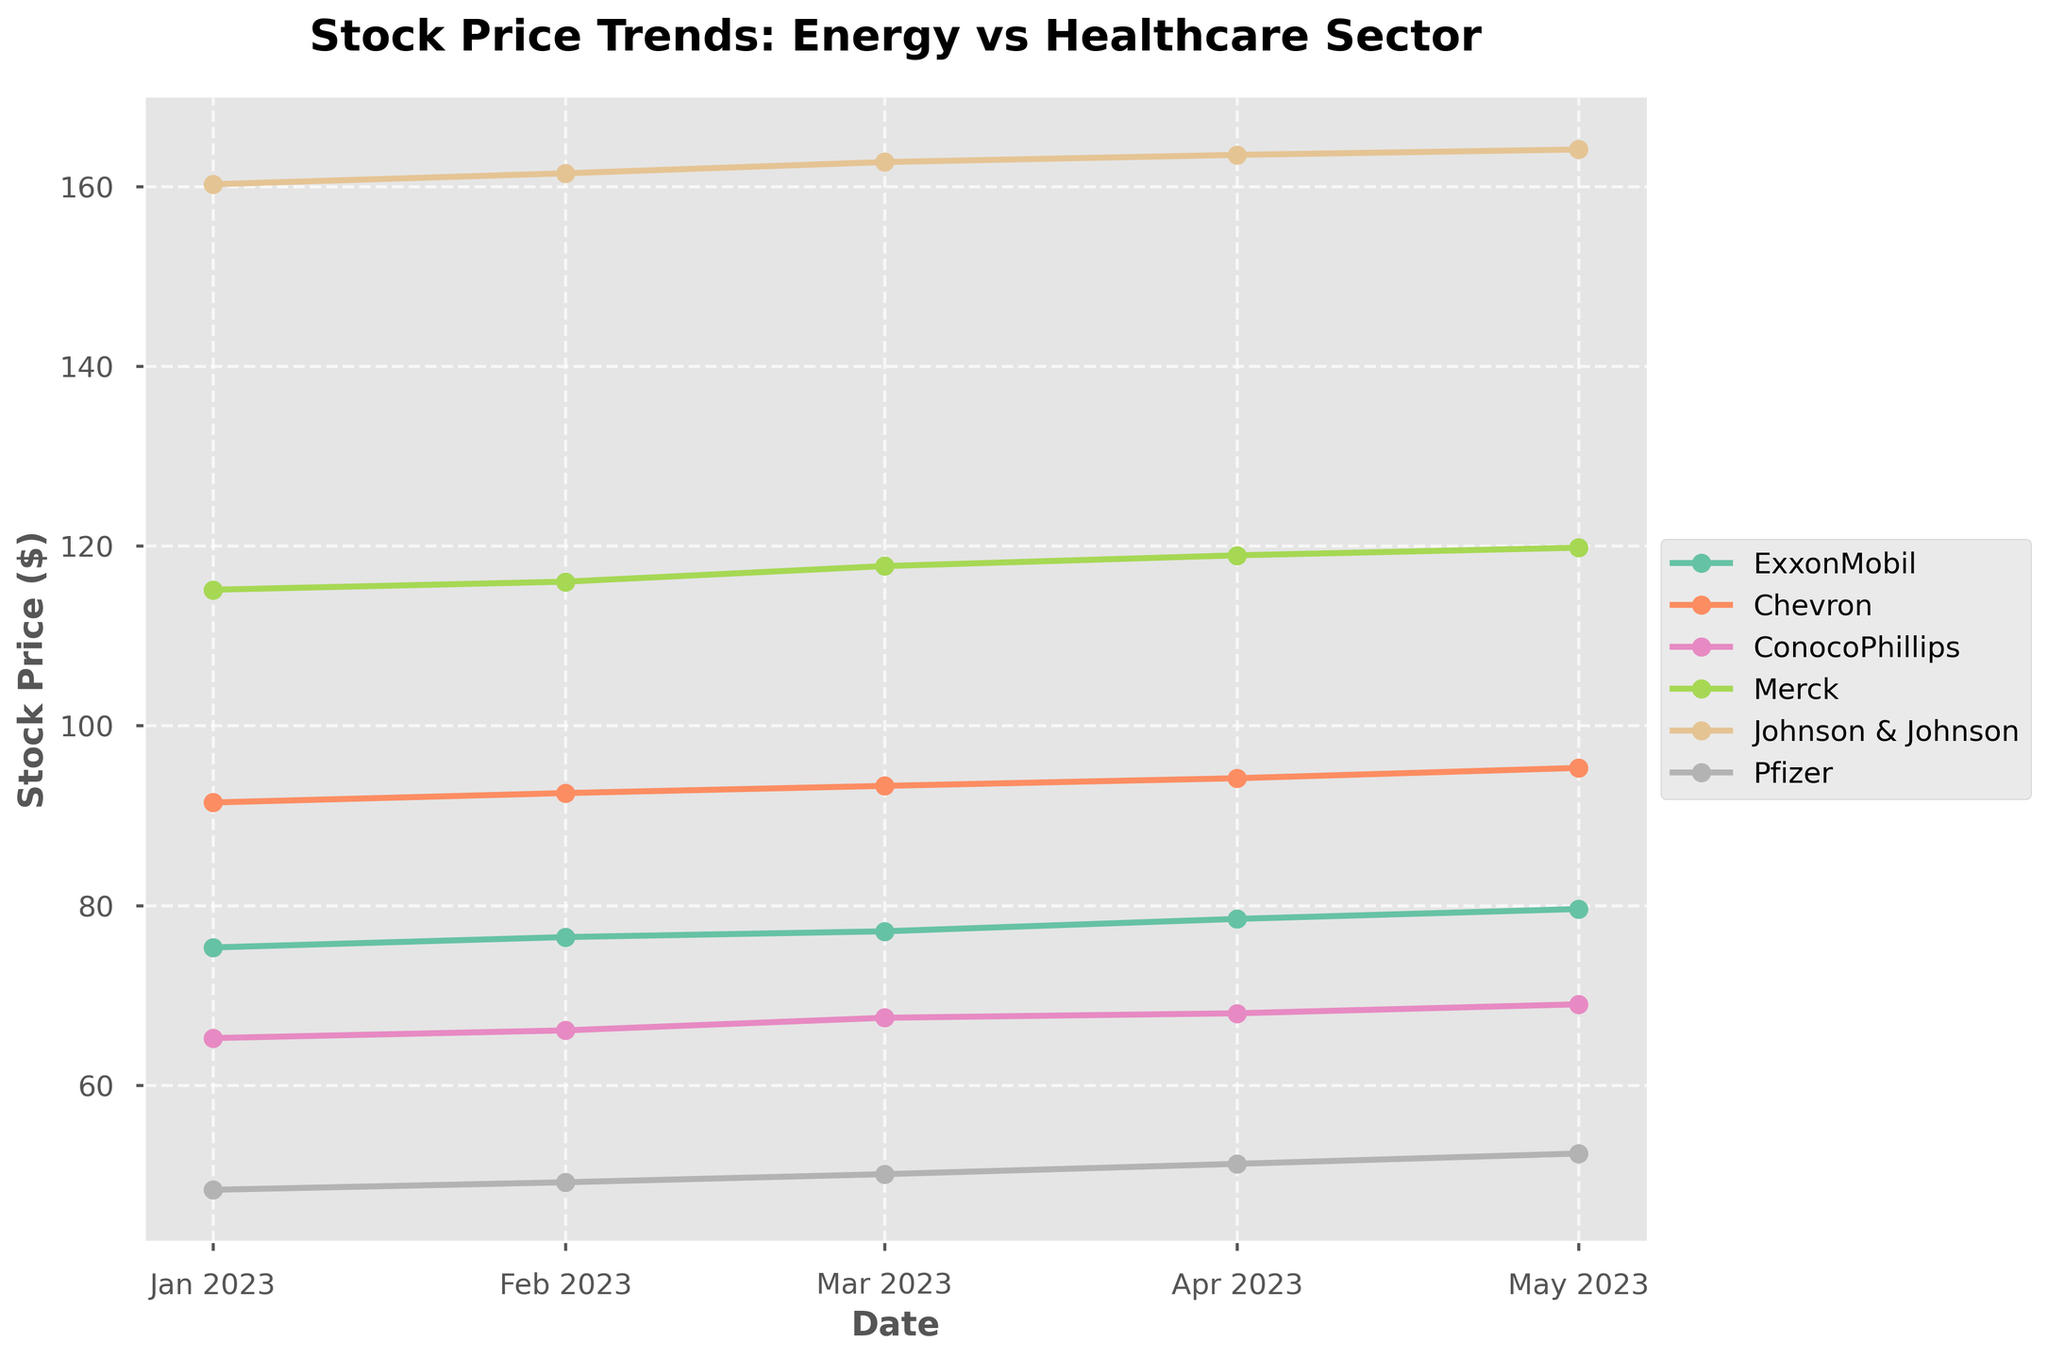What is the title of the figure? The title is usually at the top of the figure and provides a brief description of what the plot represents. In this case, it's "Stock Price Trends: Energy vs Healthcare Sector" indicating that the plot compares stock price trends between two sectors.
Answer: Stock Price Trends: Energy vs Healthcare Sector How many companies are listed in the figure? Counting the number of different companies in the legend or along the plot lines will give this information. There are six companies plotted.
Answer: 6 Which company had the highest stock price in January 2023? By looking at the plot and the values in January 2023, the highest stock price can be identified. Johnson & Johnson with a stock price of $160.23 is the highest.
Answer: Johnson & Johnson Between February and March 2023, which company's stock price increased the most? Check the stock prices in February and March, calculate the difference for each company, and identify the highest increase. Chevron's stock price increased from $92.50 to $93.30, which is an increase of $0.80.
Answer: Chevron Across the whole period, which company consistently had the highest dividend yield? Compare the dividend yield values across all months for each company. Pfizer has the highest yield every month with values like 4.2%, 4.1%, 3.9%, 4.0%, and 4.3%.
Answer: Pfizer Which sector had higher average stock prices in April 2023, Energy or Healthcare? First, find the stock prices in April 2023 for each sector, then compute the average for each. Energy sector (ExxonMobil, Chevron, ConocoPhillips): (78.50 + 94.15 + 68.00) / 3 = 80.88. Healthcare sector (Merck, Johnson & Johnson, Pfizer): (118.95 + 163.50 + 51.25) / 3 = 111.23.
Answer: Healthcare Which company shows the most fluctuation in stock price over the five months? By calculating the range (max - min) for stock prices of each company, the one with the greatest range shows the most fluctuation. Johnson & Johnson fluctuates between $160.23 and $164.10, which is a range of $3.87.
Answer: Johnson & Johnson Did any company's stock price decrease for three consecutive months? Check the stock prices month by month for each company to see if there is a continuous decrease over three months. Pfizer decreased in March, April, and May from $50.10 to $49.20 and further to $48.36.
Answer: Pfizer What's the trend of Pfizer's stock price over the period? Noting the stock price points for Pfizer from January to May can show the trend visually. The prices drift upwards from January to May: $48.36, $49.20, $50.10, $51.25, $52.40.
Answer: Increasing 